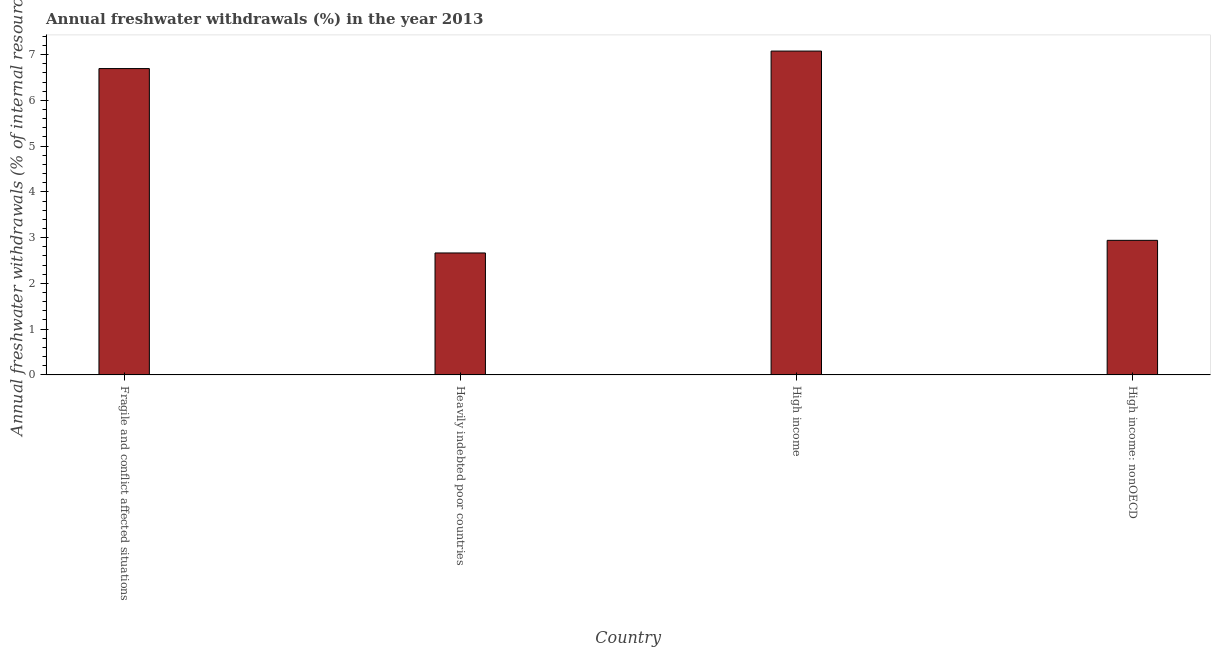Does the graph contain grids?
Offer a terse response. No. What is the title of the graph?
Give a very brief answer. Annual freshwater withdrawals (%) in the year 2013. What is the label or title of the X-axis?
Provide a short and direct response. Country. What is the label or title of the Y-axis?
Offer a terse response. Annual freshwater withdrawals (% of internal resources). What is the annual freshwater withdrawals in Heavily indebted poor countries?
Provide a short and direct response. 2.66. Across all countries, what is the maximum annual freshwater withdrawals?
Make the answer very short. 7.08. Across all countries, what is the minimum annual freshwater withdrawals?
Offer a very short reply. 2.66. In which country was the annual freshwater withdrawals maximum?
Provide a short and direct response. High income. In which country was the annual freshwater withdrawals minimum?
Offer a very short reply. Heavily indebted poor countries. What is the sum of the annual freshwater withdrawals?
Keep it short and to the point. 19.38. What is the difference between the annual freshwater withdrawals in High income and High income: nonOECD?
Your response must be concise. 4.14. What is the average annual freshwater withdrawals per country?
Provide a short and direct response. 4.84. What is the median annual freshwater withdrawals?
Provide a short and direct response. 4.82. What is the ratio of the annual freshwater withdrawals in High income to that in High income: nonOECD?
Offer a very short reply. 2.41. Is the annual freshwater withdrawals in Fragile and conflict affected situations less than that in Heavily indebted poor countries?
Provide a succinct answer. No. What is the difference between the highest and the second highest annual freshwater withdrawals?
Offer a very short reply. 0.38. What is the difference between the highest and the lowest annual freshwater withdrawals?
Give a very brief answer. 4.41. In how many countries, is the annual freshwater withdrawals greater than the average annual freshwater withdrawals taken over all countries?
Your answer should be very brief. 2. What is the Annual freshwater withdrawals (% of internal resources) in Fragile and conflict affected situations?
Offer a terse response. 6.69. What is the Annual freshwater withdrawals (% of internal resources) of Heavily indebted poor countries?
Offer a very short reply. 2.66. What is the Annual freshwater withdrawals (% of internal resources) of High income?
Provide a short and direct response. 7.08. What is the Annual freshwater withdrawals (% of internal resources) of High income: nonOECD?
Ensure brevity in your answer.  2.94. What is the difference between the Annual freshwater withdrawals (% of internal resources) in Fragile and conflict affected situations and Heavily indebted poor countries?
Your answer should be compact. 4.03. What is the difference between the Annual freshwater withdrawals (% of internal resources) in Fragile and conflict affected situations and High income?
Your answer should be very brief. -0.38. What is the difference between the Annual freshwater withdrawals (% of internal resources) in Fragile and conflict affected situations and High income: nonOECD?
Ensure brevity in your answer.  3.75. What is the difference between the Annual freshwater withdrawals (% of internal resources) in Heavily indebted poor countries and High income?
Provide a succinct answer. -4.41. What is the difference between the Annual freshwater withdrawals (% of internal resources) in Heavily indebted poor countries and High income: nonOECD?
Offer a very short reply. -0.28. What is the difference between the Annual freshwater withdrawals (% of internal resources) in High income and High income: nonOECD?
Your response must be concise. 4.14. What is the ratio of the Annual freshwater withdrawals (% of internal resources) in Fragile and conflict affected situations to that in Heavily indebted poor countries?
Provide a short and direct response. 2.51. What is the ratio of the Annual freshwater withdrawals (% of internal resources) in Fragile and conflict affected situations to that in High income?
Ensure brevity in your answer.  0.95. What is the ratio of the Annual freshwater withdrawals (% of internal resources) in Fragile and conflict affected situations to that in High income: nonOECD?
Offer a very short reply. 2.28. What is the ratio of the Annual freshwater withdrawals (% of internal resources) in Heavily indebted poor countries to that in High income?
Provide a succinct answer. 0.38. What is the ratio of the Annual freshwater withdrawals (% of internal resources) in Heavily indebted poor countries to that in High income: nonOECD?
Keep it short and to the point. 0.91. What is the ratio of the Annual freshwater withdrawals (% of internal resources) in High income to that in High income: nonOECD?
Keep it short and to the point. 2.41. 